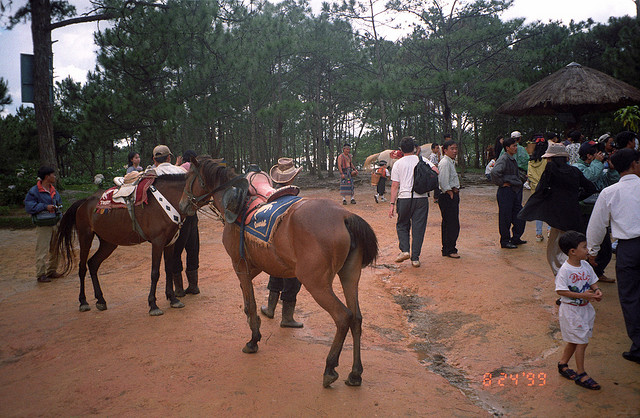<image>What year was this photo taken? I don't know what year the photo was taken. But, It can be seen as 1999. What year was this photo taken? I don't know what year this photo was taken. It seems like it was taken in 1999. 